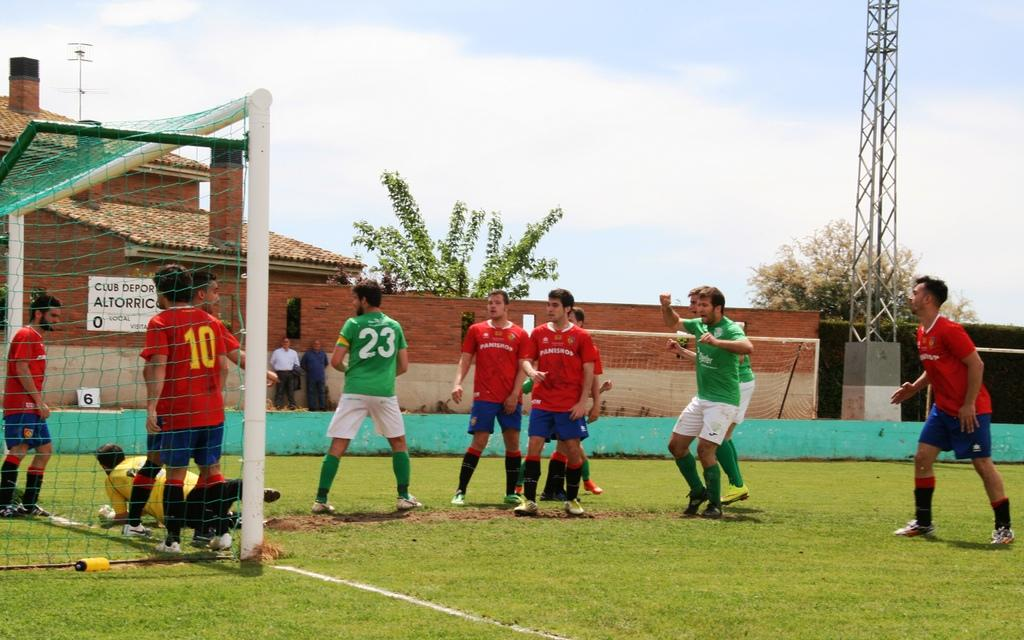<image>
Relay a brief, clear account of the picture shown. Group of athletes playing soccer with number 23 in the middle. 